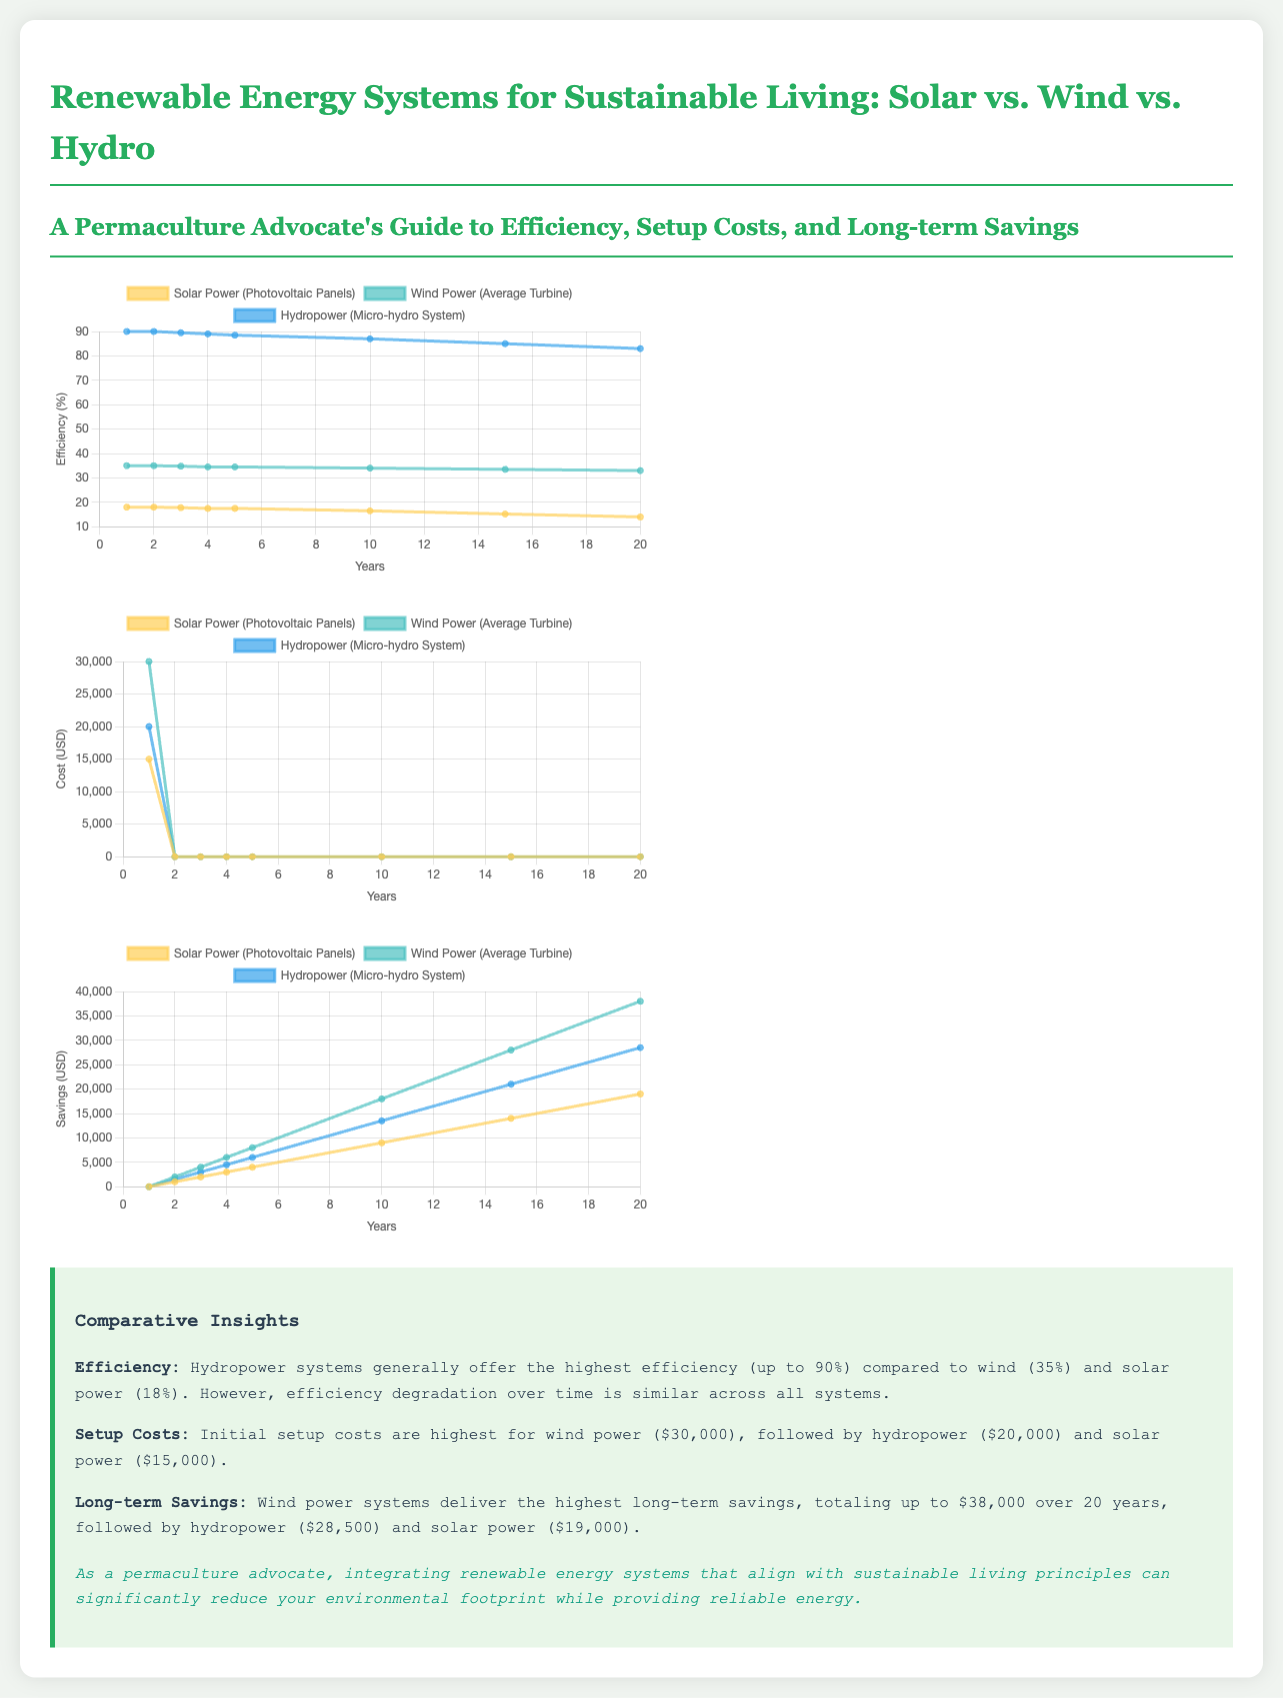What is the highest efficiency of Hydropower? The document states that Hydropower systems can offer an efficiency of up to 90%.
Answer: 90% What is the initial setup cost for Wind Power? According to the document, the initial setup cost for Wind Power is $30,000.
Answer: $30,000 Which renewable energy system delivers the highest long-term savings? The summary mentions that Wind Power systems deliver the highest long-term savings totaling up to $38,000 over 20 years.
Answer: Wind Power What is the efficiency of Solar Power after 20 years? As per the data presented, the efficiency of Solar Power after 20 years is 14%.
Answer: 14% What are the setup costs for Solar Power? The document indicates that the initial setup cost for Solar Power is $15,000.
Answer: $15,000 How much long-term savings does Hydropower provide over 20 years? The document states that Hydropower offers long-term savings of $28,500 over 20 years.
Answer: $28,500 Which system has the lowest setup cost? From the comparisons presented, Solar Power has the lowest setup cost.
Answer: Solar Power What is the approximate efficiency of Wind Power after 10 years? The summary indicates that the efficiency of Wind Power after 10 years is approximately 34%.
Answer: 34% Which renewable energy source would you choose for the greatest long-term savings? Planning based on the data would suggest choosing Wind Power for the greatest long-term savings.
Answer: Wind Power 